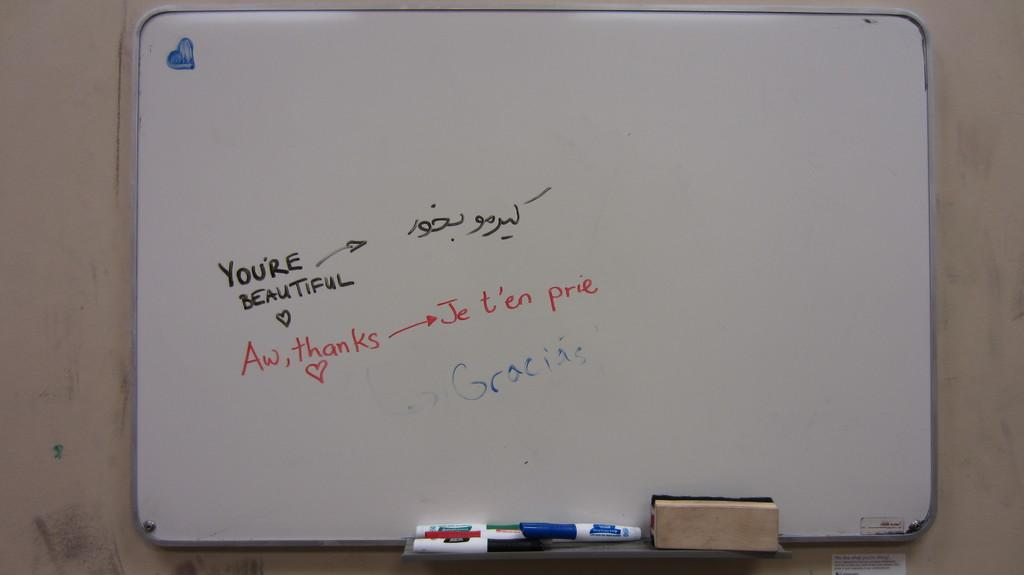What is the main object in the image? There is a white board in the image. What is written or drawn on the white board? There is text on the white board. What can be seen behind the white board? There is a wall in the background of the image. What tools are present in the front of the image? There are markers and a duster in the front of the image. How many divisions are visible on the shelf in the image? There is no shelf present in the image; it features a white board with text, a wall in the background, and markers and a duster in the front. 